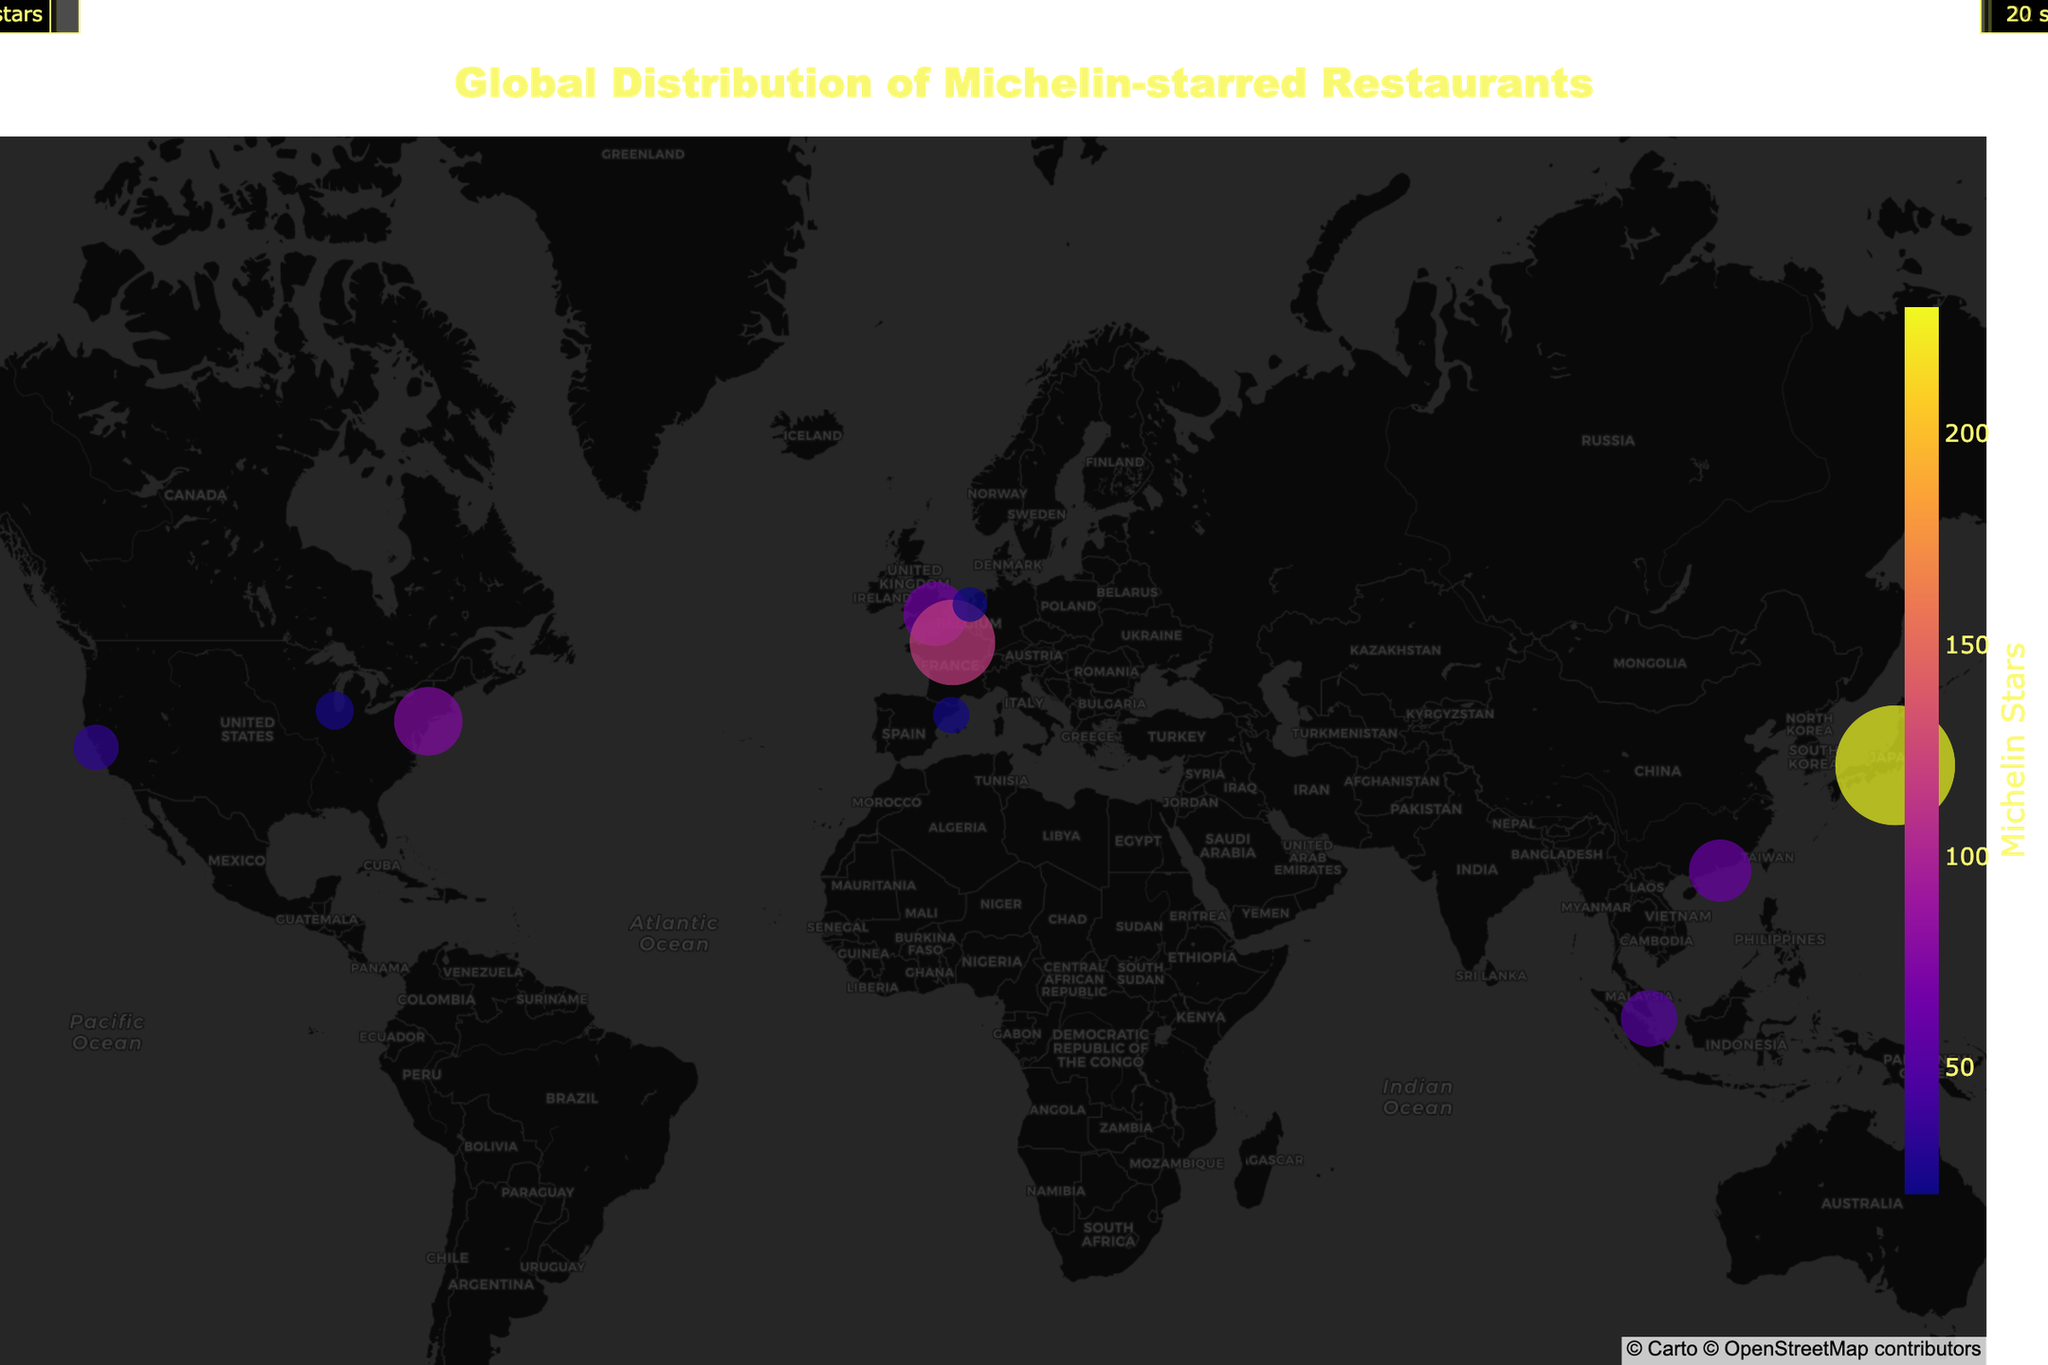How many Michelin stars does Tokyo have? Tokyo has 230 Michelin stars, which is displayed on the figure as the largest bubble with the highest number. The size and color intensity of the bubble indicate the high count.
Answer: 230 Which city has the second most Michelin stars after Tokyo? Paris has the second most Michelin stars. The figure shows Paris with 118 stars, which is the second largest and intense colored bubble after Tokyo.
Answer: Paris What is the sum of Michelin stars for all the cities in the USA listed on the map? The USA cities listed are New York, San Francisco, and Chicago with 76, 34, and 24 stars respectively. Adding these up results in 76 + 34 + 24 = 134 Michelin stars.
Answer: 134 Which city in Europe has the highest number of Michelin stars? Paris leads among European cities with 118 Michelin stars, as indicated by the largest and most intense bubble in Europe on the figure.
Answer: Paris Compare the Michelin stars of New York and London. Which one has more? New York has 76 Michelin stars, while London has 67. According to the plot, New York has more Michelin stars than London.
Answer: New York Is there any city in the Southern Hemisphere with Michelin-starred restaurants according to the figure? Singapore is located close to the equator but is in the Northern Hemisphere. The figure does not show any cities in the Southern Hemisphere with Michelin-starred restaurants.
Answer: No What is the average number of Michelin stars for the cities listed? To find the average, sum up the Michelin stars for all the cities (230 + 118 + 76 + 67 + 63 + 52 + 34 + 24 + 22 + 20 = 706) and divide by the number of cities (10). 706 / 10 = 70.6.
Answer: 70.6 Among the cities listed, which has the fewest Michelin stars? Amsterdam has the fewest Michelin stars, with a total of 20, as shown by the smallest bubble on the plot.
Answer: Amsterdam Which city in Asia has more Michelin stars, Hong Kong or Singapore? Hong Kong has 63 Michelin stars, while Singapore has 52. Thus, Hong Kong has more Michelin stars than Singapore based on the plot.
Answer: Hong Kong 